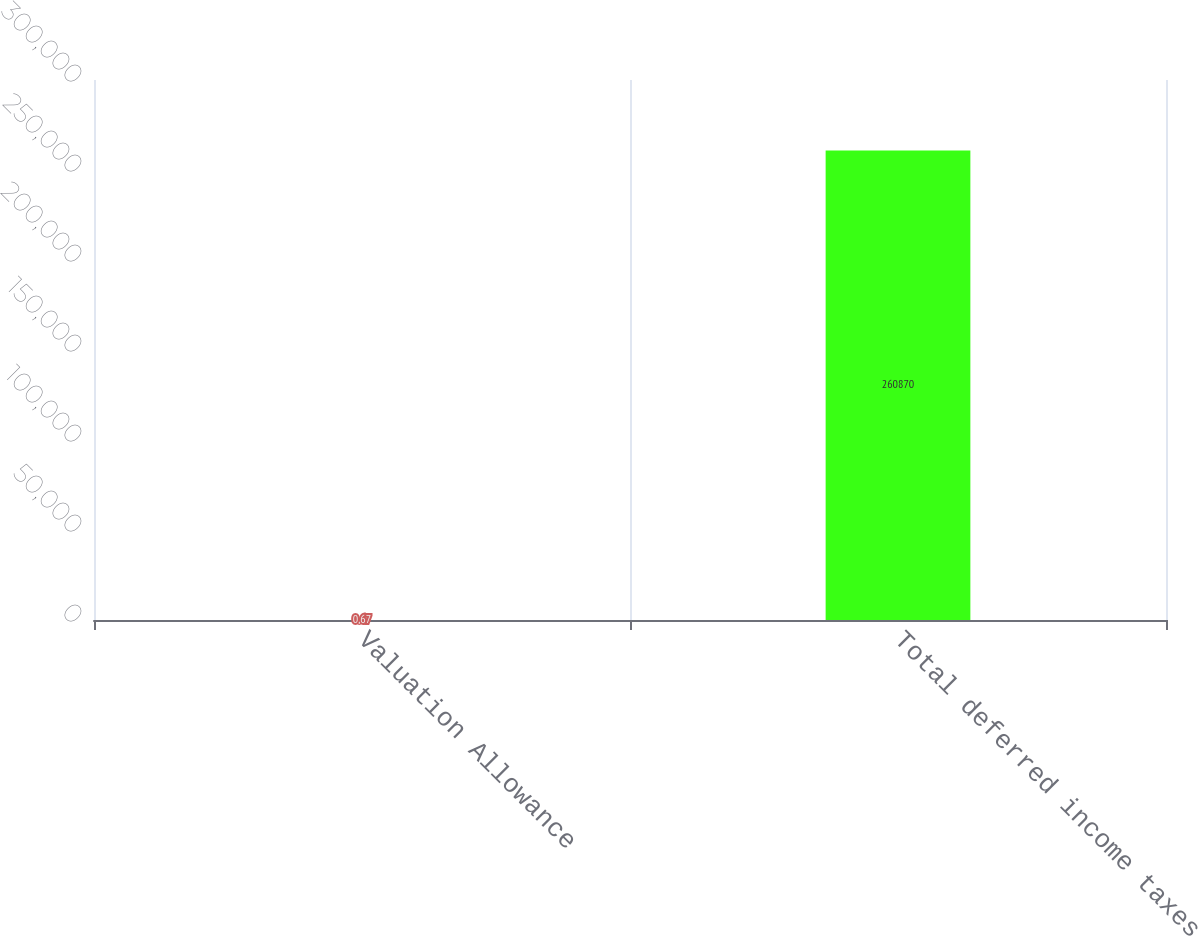Convert chart to OTSL. <chart><loc_0><loc_0><loc_500><loc_500><bar_chart><fcel>Valuation Allowance<fcel>Total deferred income taxes<nl><fcel>0.67<fcel>260870<nl></chart> 